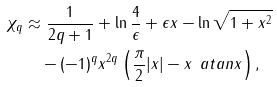Convert formula to latex. <formula><loc_0><loc_0><loc_500><loc_500>\chi _ { q } & \approx \frac { 1 } { 2 q + 1 } + \ln \frac { 4 } { \epsilon } + \epsilon x - \ln \sqrt { 1 + x ^ { 2 } } \\ & \quad - ( - 1 ) ^ { q } x ^ { 2 q } \left ( \frac { \pi } { 2 } | x | - x \, \ a t a n x \right ) ,</formula> 